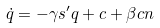<formula> <loc_0><loc_0><loc_500><loc_500>\dot { q } = - \gamma s ^ { \prime } q + c + \beta c n</formula> 